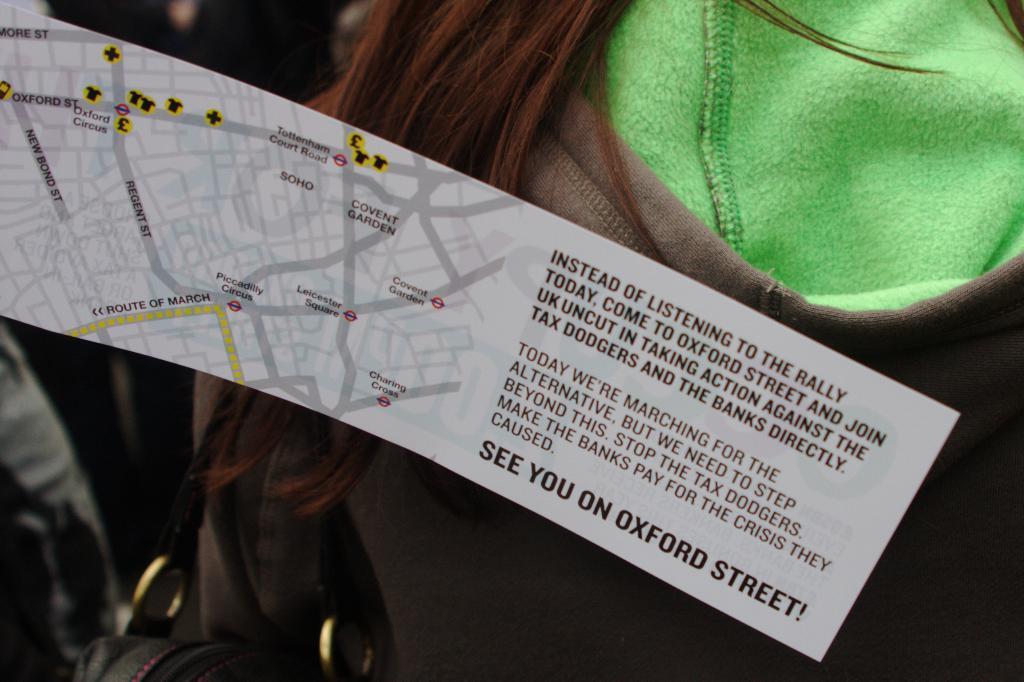In one or two sentences, can you explain what this image depicts? In this image in front there is a paper on which there is a map and there is some text. Behind the paper there is a person wearing a jacket. 